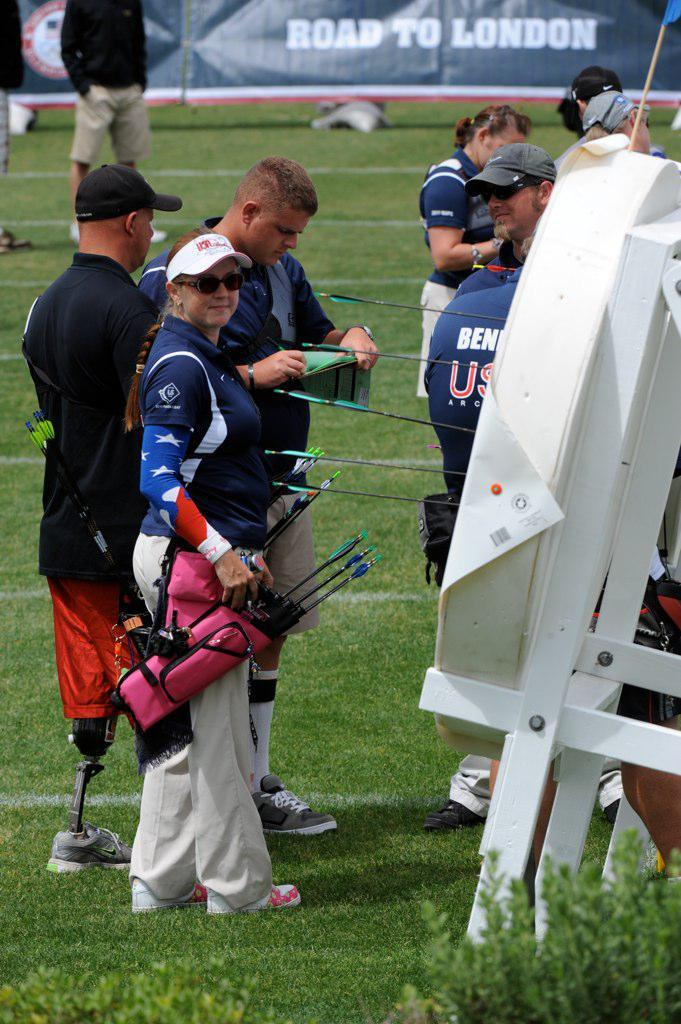<image>
Create a compact narrative representing the image presented. A gathering of people at an archery field stand in front of a sign that says "Road to London". 